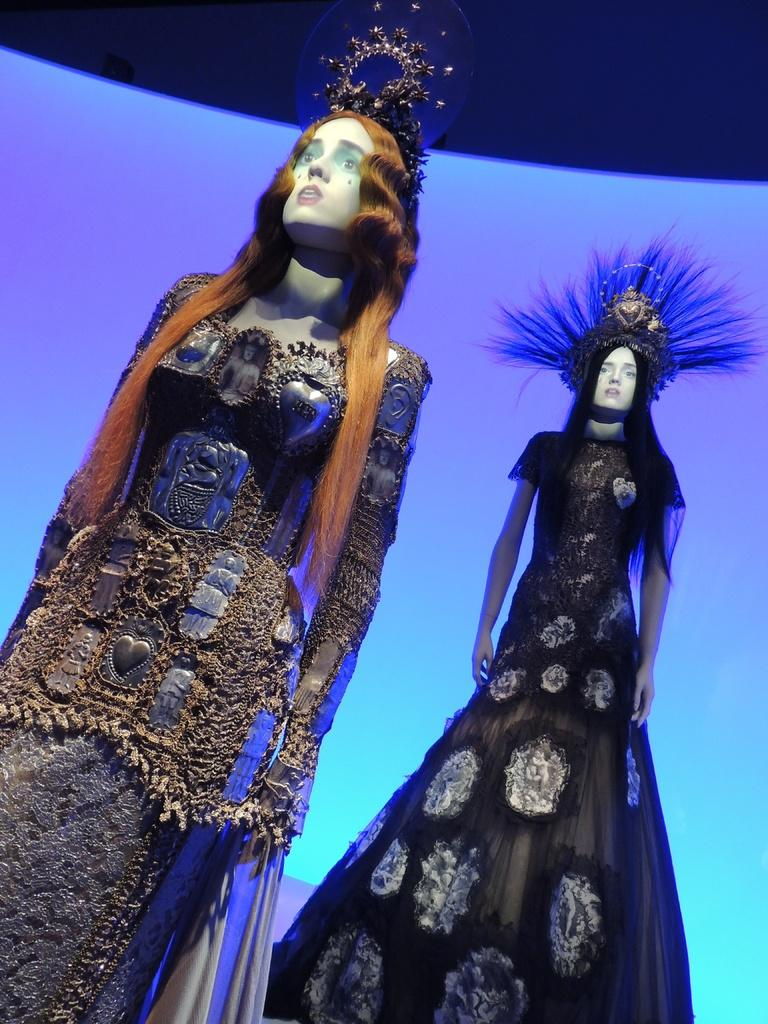What is the main subject of the image? The main subject of the image is a car parked on the side of the road. Can you describe the location of the car in the image? The car is parked on the side of the road. Is there anyone near the car in the image? The transcript does not mention anyone near the car, so we cannot definitively answer that question. What can be seen in the background of the image? The transcript mentions that there is a person, but it does not specify their location or what they are doing. However, it does mention that there are trees and grass in the background. What type of scene is depicted on the car's stitching in the image? There is no mention of any stitching or design on the car in the image, so we cannot answer that question. 